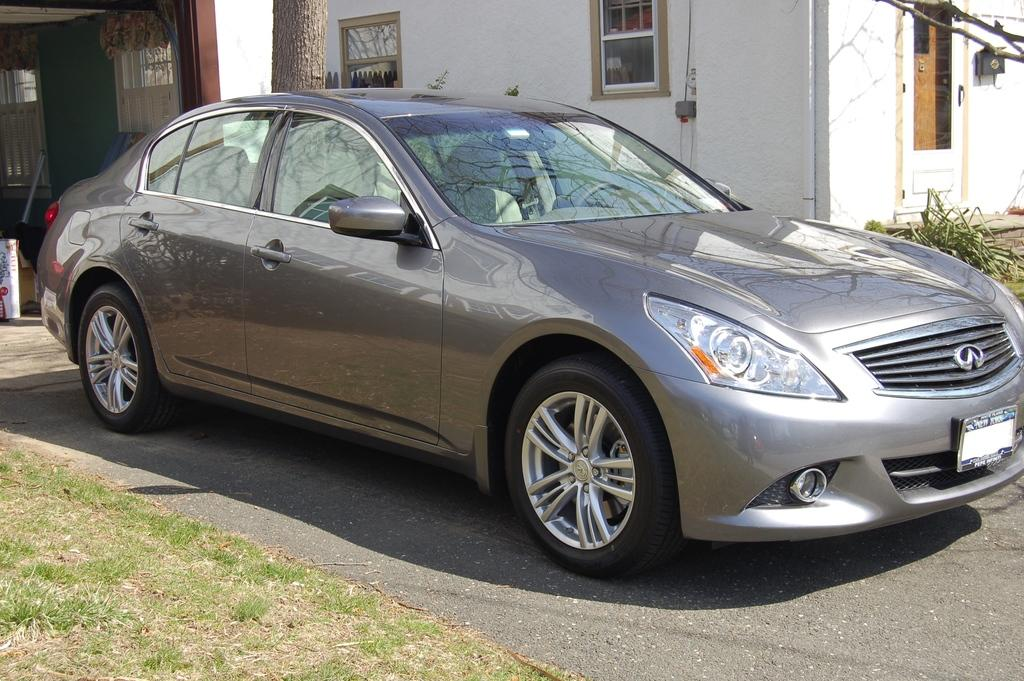What is visible in the foreground of the image? In the foreground of the image, there is grass, a road, and a car. Can you describe the background of the image? In the background of the image, there is a house, a tree, a plant, windows, and other objects. What type of surface is visible in the foreground? The road in the foreground is a type of surface. How many objects can be seen in the background? There are at least six objects visible in the background: a house, a tree, a plant, windows, and other objects. What is the maid doing in the image? There is no maid present in the image. What is the fear of the person in the image? There is no person or fear mentioned in the image. 